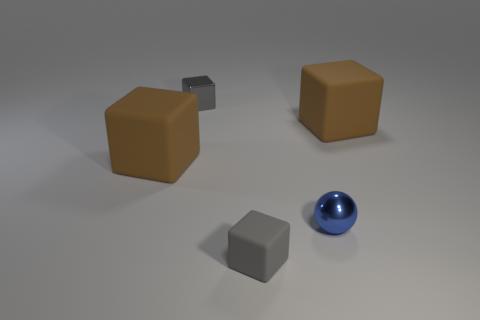How many other things have the same color as the tiny matte thing?
Give a very brief answer. 1. The tiny shiny thing that is the same shape as the gray rubber object is what color?
Your answer should be very brief. Gray. What shape is the small thing that is both to the right of the metal cube and behind the small rubber cube?
Keep it short and to the point. Sphere. Is the number of big cyan matte cylinders greater than the number of gray blocks?
Provide a short and direct response. No. What is the small blue ball made of?
Provide a short and direct response. Metal. Are there any other things that have the same size as the gray metallic block?
Provide a short and direct response. Yes. The shiny thing that is the same shape as the small gray rubber thing is what size?
Offer a terse response. Small. Are there any gray matte blocks that are to the left of the tiny gray object that is left of the small gray matte cube?
Give a very brief answer. No. Does the metallic ball have the same color as the tiny rubber object?
Provide a short and direct response. No. What number of other objects are the same shape as the gray rubber object?
Provide a succinct answer. 3. 